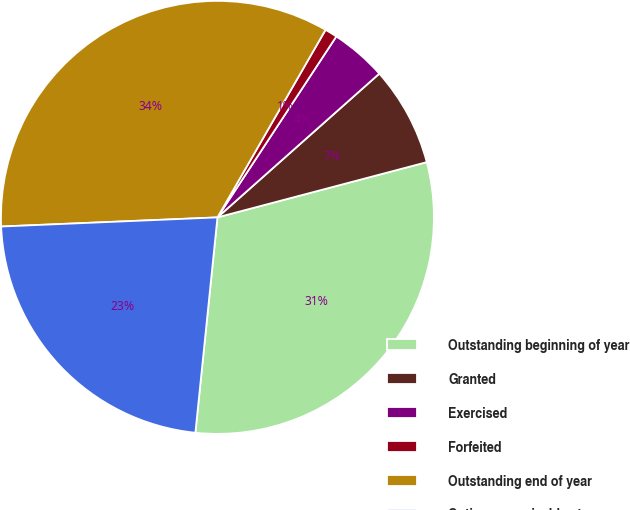Convert chart to OTSL. <chart><loc_0><loc_0><loc_500><loc_500><pie_chart><fcel>Outstanding beginning of year<fcel>Granted<fcel>Exercised<fcel>Forfeited<fcel>Outstanding end of year<fcel>Options exercisable at year<nl><fcel>30.73%<fcel>7.45%<fcel>4.19%<fcel>0.93%<fcel>33.99%<fcel>22.7%<nl></chart> 